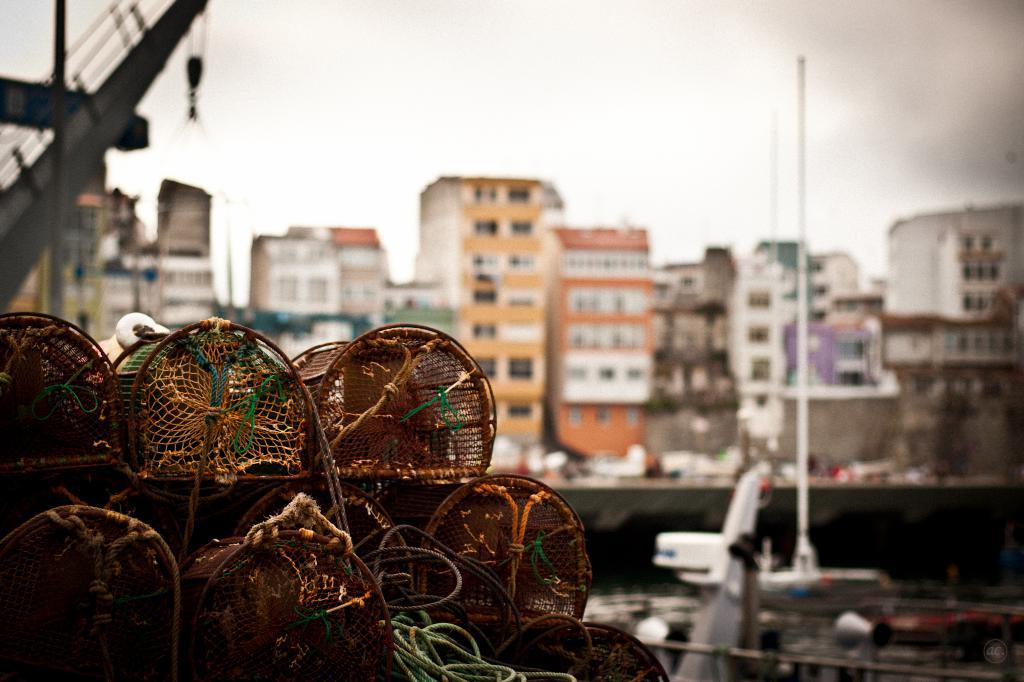What objects can be seen in the image related to restraint or support? There are ropes and cages in the image. What is located behind the cages in the image? There is a pole behind the cages. What can be seen in the background of the image? Buildings and the sky are visible in the background. What might be causing the blurred appearance of some objects in the image? There are some blurred things in the image, which could be due to movement or focus issues. What type of dinner is being served in the image? There is no dinner or any food visible in the image. What is the source of the crying sound in the image? There is no crying sound or any indication of sound in the image. 